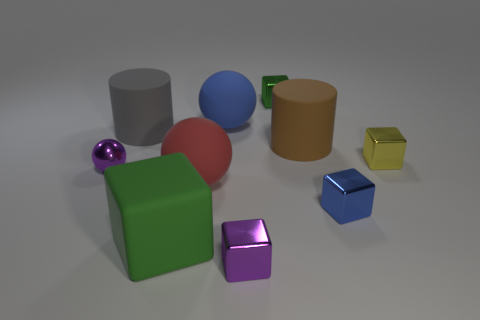Is the number of purple objects behind the tiny yellow object greater than the number of blue rubber balls?
Make the answer very short. No. The small metallic cube that is behind the large brown cylinder is what color?
Your answer should be very brief. Green. Do the yellow metallic object and the rubber cube have the same size?
Offer a terse response. No. How big is the blue shiny object?
Ensure brevity in your answer.  Small. There is a tiny thing that is the same color as the small shiny ball; what is its shape?
Keep it short and to the point. Cube. Is the number of yellow metallic blocks greater than the number of big rubber cylinders?
Keep it short and to the point. No. What is the color of the ball behind the big rubber cylinder that is on the right side of the small metal block behind the gray rubber thing?
Give a very brief answer. Blue. There is a small shiny thing that is behind the big brown thing; does it have the same shape as the red object?
Ensure brevity in your answer.  No. The metal ball that is the same size as the green metallic thing is what color?
Give a very brief answer. Purple. What number of green cubes are there?
Offer a very short reply. 2. 